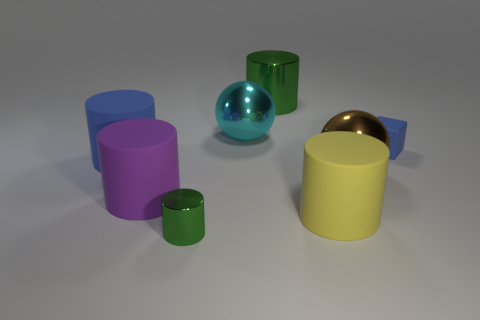Subtract all large shiny cylinders. How many cylinders are left? 4 Subtract all blue balls. How many green cylinders are left? 2 Subtract all yellow cylinders. How many cylinders are left? 4 Subtract 1 cylinders. How many cylinders are left? 4 Add 1 large green cylinders. How many objects exist? 9 Subtract all gray cylinders. Subtract all yellow cubes. How many cylinders are left? 5 Subtract all blocks. How many objects are left? 7 Subtract 0 purple balls. How many objects are left? 8 Subtract all big matte cylinders. Subtract all purple cylinders. How many objects are left? 4 Add 8 big balls. How many big balls are left? 10 